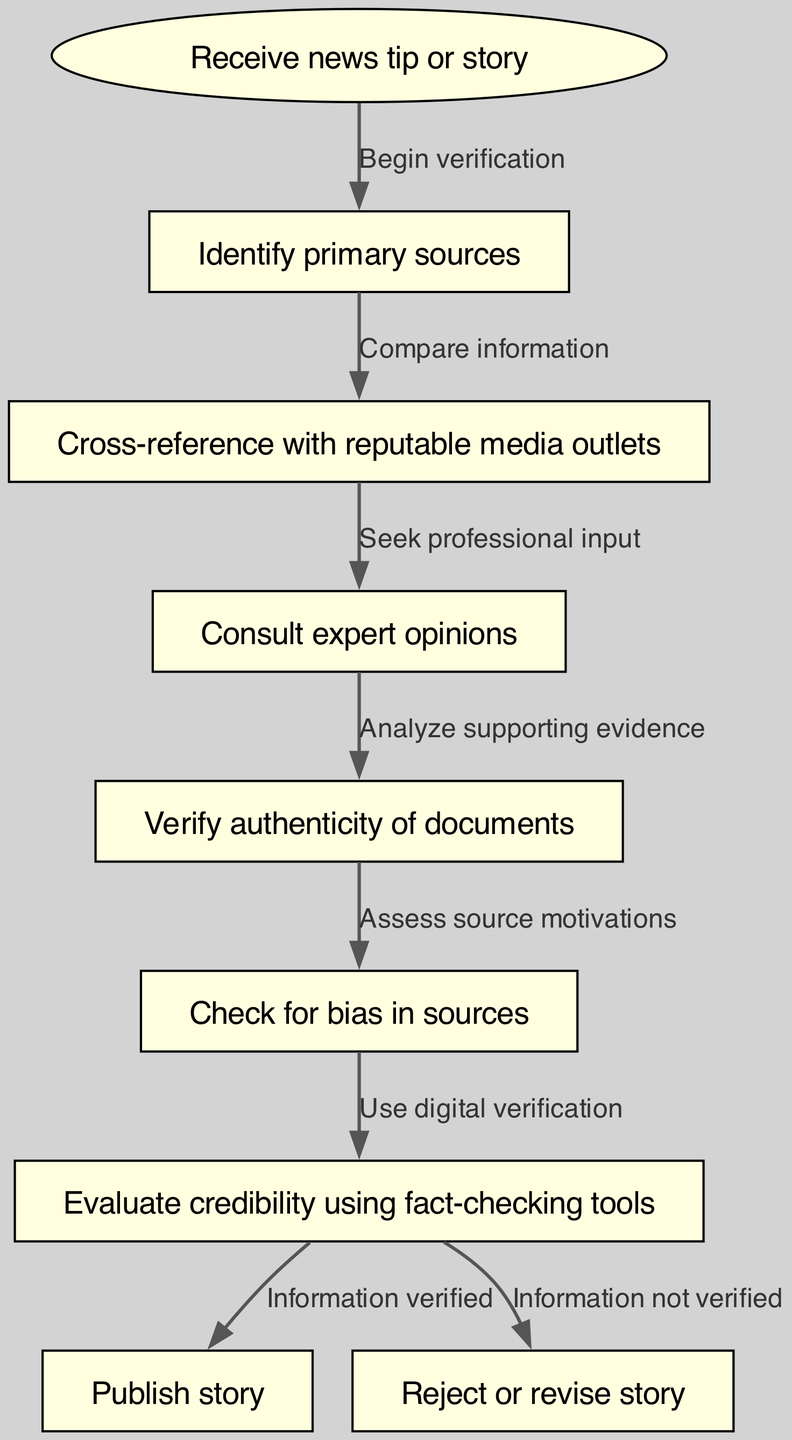What is the first step in the fact-checking process? The first step in the flowchart is "Receive news tip or story," which indicates the initiation of the fact-checking process.
Answer: Receive news tip or story How many total nodes are present in the diagram? By counting each unique step displayed in the diagram, we find that there are 9 nodes listed.
Answer: 9 What does the edge from node 5 to node 6 represent? This edge indicates a transition where the verification of documents leads to assessing the source motivations, highlighting a logical flow in fact-checking.
Answer: Assess source motivations Which step follows consulting expert opinions? In the diagram, after "Consult expert opinions," the next step is "Verify authenticity of documents," establishing a sequential verification process.
Answer: Verify authenticity of documents What happens if the information is verified at node 7? If the information is verified at node 7, it leads directly to publishing the story, as indicated by the connected edge with the label "Information verified."
Answer: Publish story What is the significance of node 6 in terms of evaluating sources? Node 6 involves checking for bias in sources, which is a crucial part of ensuring credibility and neutrality before finalizing the story.
Answer: Checking for bias If the information is not verified, where does it lead to in the flowchart? If the information is not verified at node 7, it leads to "Reject or revise story," demonstrating the process of handling inaccurate or questionable information.
Answer: Reject or revise story How does the fact-checking process begin? The process begins with receiving a news tip or story, which is denoted by the first node in the diagram labeled as "Receive news tip or story."
Answer: Receive news tip or story What is the role of digital verification in the process? Digital verification, indicated at node 7, is used to evaluate credibility using fact-checking tools, which enhances the reliability of the news being published.
Answer: Evaluate credibility using fact-checking tools 